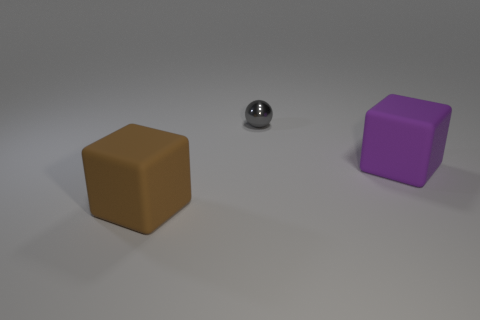Does the rubber block that is on the right side of the brown cube have the same size as the tiny gray ball?
Offer a very short reply. No. How many objects are behind the big purple block and in front of the sphere?
Your answer should be compact. 0. There is a rubber object that is behind the block that is to the left of the gray metallic object; how big is it?
Keep it short and to the point. Large. Is the number of small gray metallic objects that are left of the shiny ball less than the number of large purple matte things that are behind the brown thing?
Offer a terse response. Yes. What is the object that is on the left side of the purple rubber thing and behind the brown rubber block made of?
Give a very brief answer. Metal. Are any blue rubber cubes visible?
Give a very brief answer. No. There is a purple object that is made of the same material as the large brown cube; what shape is it?
Provide a short and direct response. Cube. There is a big purple rubber thing; is its shape the same as the thing that is left of the small thing?
Provide a short and direct response. Yes. There is a brown object to the left of the matte object that is on the right side of the small object; what is it made of?
Make the answer very short. Rubber. How many other things are the same shape as the brown thing?
Your answer should be compact. 1. 